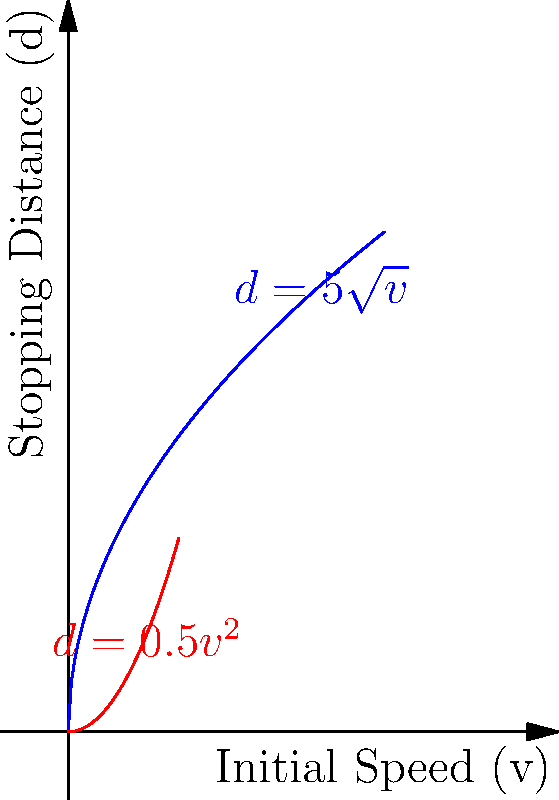A traffic officer is analyzing the relationship between a vehicle's initial speed (v) and its stopping distance (d) on two different road conditions. On a straight, dry road, the relationship is given by $d = 0.5v^2$. On a curved, wet road, the relationship is $d = 5\sqrt{v}$. At what initial speed will the stopping distances be equal for both road conditions? Use implicit differentiation to find the rate of change of stopping distance with respect to initial speed at this point for the curved, wet road. Step 1: Find the initial speed where stopping distances are equal.
$0.5v^2 = 5\sqrt{v}$
$v^2 = 10\sqrt{v}$
$v^{3/2} = 10$
$v = (\frac{10}{1})^{2/3} = 4.64$ m/s

Step 2: For the curved, wet road, $d = 5\sqrt{v}$. Implicitly differentiate both sides with respect to v:
$\frac{dd}{dv} = 5 \cdot \frac{1}{2\sqrt{v}}$

Step 3: Substitute v = 4.64 into the derivative:
$\frac{dd}{dv} = 5 \cdot \frac{1}{2\sqrt{4.64}} = \frac{5}{2\sqrt{4.64}} = 1.16$

Therefore, at the initial speed of 4.64 m/s, the rate of change of stopping distance with respect to initial speed on the curved, wet road is 1.16 m/(m/s).
Answer: 1.16 m/(m/s) 